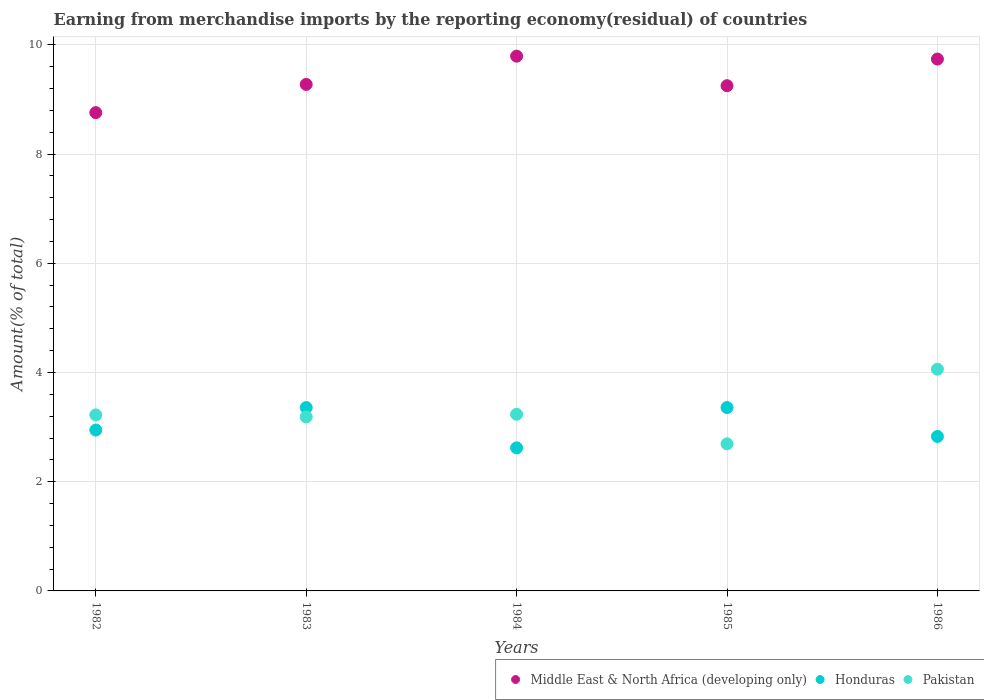How many different coloured dotlines are there?
Provide a succinct answer. 3. Is the number of dotlines equal to the number of legend labels?
Keep it short and to the point. Yes. What is the percentage of amount earned from merchandise imports in Middle East & North Africa (developing only) in 1984?
Provide a succinct answer. 9.79. Across all years, what is the maximum percentage of amount earned from merchandise imports in Honduras?
Ensure brevity in your answer.  3.36. Across all years, what is the minimum percentage of amount earned from merchandise imports in Honduras?
Offer a terse response. 2.62. What is the total percentage of amount earned from merchandise imports in Middle East & North Africa (developing only) in the graph?
Give a very brief answer. 46.82. What is the difference between the percentage of amount earned from merchandise imports in Pakistan in 1982 and that in 1983?
Your answer should be compact. 0.04. What is the difference between the percentage of amount earned from merchandise imports in Pakistan in 1983 and the percentage of amount earned from merchandise imports in Middle East & North Africa (developing only) in 1982?
Make the answer very short. -5.57. What is the average percentage of amount earned from merchandise imports in Honduras per year?
Keep it short and to the point. 3.02. In the year 1986, what is the difference between the percentage of amount earned from merchandise imports in Pakistan and percentage of amount earned from merchandise imports in Honduras?
Provide a succinct answer. 1.23. In how many years, is the percentage of amount earned from merchandise imports in Pakistan greater than 4 %?
Give a very brief answer. 1. What is the ratio of the percentage of amount earned from merchandise imports in Pakistan in 1983 to that in 1985?
Provide a short and direct response. 1.18. Is the percentage of amount earned from merchandise imports in Pakistan in 1982 less than that in 1984?
Give a very brief answer. Yes. What is the difference between the highest and the second highest percentage of amount earned from merchandise imports in Honduras?
Provide a short and direct response. 4.01576993880326e-9. What is the difference between the highest and the lowest percentage of amount earned from merchandise imports in Honduras?
Offer a terse response. 0.74. Is the sum of the percentage of amount earned from merchandise imports in Honduras in 1983 and 1986 greater than the maximum percentage of amount earned from merchandise imports in Middle East & North Africa (developing only) across all years?
Make the answer very short. No. Does the percentage of amount earned from merchandise imports in Honduras monotonically increase over the years?
Give a very brief answer. No. Is the percentage of amount earned from merchandise imports in Pakistan strictly greater than the percentage of amount earned from merchandise imports in Middle East & North Africa (developing only) over the years?
Offer a very short reply. No. How many dotlines are there?
Keep it short and to the point. 3. How many years are there in the graph?
Your answer should be very brief. 5. Are the values on the major ticks of Y-axis written in scientific E-notation?
Your answer should be compact. No. Does the graph contain any zero values?
Offer a very short reply. No. Does the graph contain grids?
Your answer should be compact. Yes. Where does the legend appear in the graph?
Make the answer very short. Bottom right. What is the title of the graph?
Your answer should be compact. Earning from merchandise imports by the reporting economy(residual) of countries. Does "Finland" appear as one of the legend labels in the graph?
Your response must be concise. No. What is the label or title of the Y-axis?
Keep it short and to the point. Amount(% of total). What is the Amount(% of total) in Middle East & North Africa (developing only) in 1982?
Your response must be concise. 8.76. What is the Amount(% of total) of Honduras in 1982?
Your answer should be compact. 2.95. What is the Amount(% of total) of Pakistan in 1982?
Ensure brevity in your answer.  3.22. What is the Amount(% of total) of Middle East & North Africa (developing only) in 1983?
Provide a short and direct response. 9.28. What is the Amount(% of total) of Honduras in 1983?
Make the answer very short. 3.36. What is the Amount(% of total) of Pakistan in 1983?
Offer a terse response. 3.19. What is the Amount(% of total) of Middle East & North Africa (developing only) in 1984?
Offer a very short reply. 9.79. What is the Amount(% of total) in Honduras in 1984?
Provide a short and direct response. 2.62. What is the Amount(% of total) of Pakistan in 1984?
Give a very brief answer. 3.23. What is the Amount(% of total) in Middle East & North Africa (developing only) in 1985?
Make the answer very short. 9.25. What is the Amount(% of total) of Honduras in 1985?
Keep it short and to the point. 3.36. What is the Amount(% of total) in Pakistan in 1985?
Your answer should be very brief. 2.69. What is the Amount(% of total) of Middle East & North Africa (developing only) in 1986?
Give a very brief answer. 9.74. What is the Amount(% of total) in Honduras in 1986?
Ensure brevity in your answer.  2.83. What is the Amount(% of total) of Pakistan in 1986?
Offer a very short reply. 4.06. Across all years, what is the maximum Amount(% of total) in Middle East & North Africa (developing only)?
Offer a terse response. 9.79. Across all years, what is the maximum Amount(% of total) of Honduras?
Your response must be concise. 3.36. Across all years, what is the maximum Amount(% of total) of Pakistan?
Your answer should be compact. 4.06. Across all years, what is the minimum Amount(% of total) in Middle East & North Africa (developing only)?
Provide a succinct answer. 8.76. Across all years, what is the minimum Amount(% of total) in Honduras?
Give a very brief answer. 2.62. Across all years, what is the minimum Amount(% of total) of Pakistan?
Keep it short and to the point. 2.69. What is the total Amount(% of total) of Middle East & North Africa (developing only) in the graph?
Your response must be concise. 46.82. What is the total Amount(% of total) in Honduras in the graph?
Offer a very short reply. 15.11. What is the total Amount(% of total) in Pakistan in the graph?
Provide a succinct answer. 16.4. What is the difference between the Amount(% of total) of Middle East & North Africa (developing only) in 1982 and that in 1983?
Offer a very short reply. -0.52. What is the difference between the Amount(% of total) in Honduras in 1982 and that in 1983?
Your answer should be very brief. -0.41. What is the difference between the Amount(% of total) in Pakistan in 1982 and that in 1983?
Offer a terse response. 0.04. What is the difference between the Amount(% of total) of Middle East & North Africa (developing only) in 1982 and that in 1984?
Provide a succinct answer. -1.03. What is the difference between the Amount(% of total) in Honduras in 1982 and that in 1984?
Offer a terse response. 0.33. What is the difference between the Amount(% of total) in Pakistan in 1982 and that in 1984?
Your answer should be compact. -0.01. What is the difference between the Amount(% of total) in Middle East & North Africa (developing only) in 1982 and that in 1985?
Give a very brief answer. -0.49. What is the difference between the Amount(% of total) of Honduras in 1982 and that in 1985?
Provide a short and direct response. -0.41. What is the difference between the Amount(% of total) of Pakistan in 1982 and that in 1985?
Offer a terse response. 0.53. What is the difference between the Amount(% of total) of Middle East & North Africa (developing only) in 1982 and that in 1986?
Offer a terse response. -0.98. What is the difference between the Amount(% of total) in Honduras in 1982 and that in 1986?
Provide a succinct answer. 0.12. What is the difference between the Amount(% of total) of Pakistan in 1982 and that in 1986?
Offer a very short reply. -0.84. What is the difference between the Amount(% of total) of Middle East & North Africa (developing only) in 1983 and that in 1984?
Provide a short and direct response. -0.52. What is the difference between the Amount(% of total) of Honduras in 1983 and that in 1984?
Your answer should be compact. 0.74. What is the difference between the Amount(% of total) of Pakistan in 1983 and that in 1984?
Offer a terse response. -0.05. What is the difference between the Amount(% of total) in Middle East & North Africa (developing only) in 1983 and that in 1985?
Provide a succinct answer. 0.02. What is the difference between the Amount(% of total) in Pakistan in 1983 and that in 1985?
Offer a terse response. 0.49. What is the difference between the Amount(% of total) in Middle East & North Africa (developing only) in 1983 and that in 1986?
Offer a terse response. -0.46. What is the difference between the Amount(% of total) of Honduras in 1983 and that in 1986?
Provide a short and direct response. 0.53. What is the difference between the Amount(% of total) in Pakistan in 1983 and that in 1986?
Your answer should be very brief. -0.87. What is the difference between the Amount(% of total) of Middle East & North Africa (developing only) in 1984 and that in 1985?
Offer a terse response. 0.54. What is the difference between the Amount(% of total) in Honduras in 1984 and that in 1985?
Provide a succinct answer. -0.74. What is the difference between the Amount(% of total) of Pakistan in 1984 and that in 1985?
Provide a short and direct response. 0.54. What is the difference between the Amount(% of total) of Middle East & North Africa (developing only) in 1984 and that in 1986?
Your response must be concise. 0.05. What is the difference between the Amount(% of total) in Honduras in 1984 and that in 1986?
Keep it short and to the point. -0.21. What is the difference between the Amount(% of total) of Pakistan in 1984 and that in 1986?
Provide a succinct answer. -0.83. What is the difference between the Amount(% of total) of Middle East & North Africa (developing only) in 1985 and that in 1986?
Keep it short and to the point. -0.49. What is the difference between the Amount(% of total) of Honduras in 1985 and that in 1986?
Your answer should be compact. 0.53. What is the difference between the Amount(% of total) in Pakistan in 1985 and that in 1986?
Your response must be concise. -1.37. What is the difference between the Amount(% of total) in Middle East & North Africa (developing only) in 1982 and the Amount(% of total) in Honduras in 1983?
Your response must be concise. 5.4. What is the difference between the Amount(% of total) in Middle East & North Africa (developing only) in 1982 and the Amount(% of total) in Pakistan in 1983?
Your answer should be very brief. 5.57. What is the difference between the Amount(% of total) in Honduras in 1982 and the Amount(% of total) in Pakistan in 1983?
Your answer should be very brief. -0.24. What is the difference between the Amount(% of total) of Middle East & North Africa (developing only) in 1982 and the Amount(% of total) of Honduras in 1984?
Provide a succinct answer. 6.14. What is the difference between the Amount(% of total) in Middle East & North Africa (developing only) in 1982 and the Amount(% of total) in Pakistan in 1984?
Offer a very short reply. 5.52. What is the difference between the Amount(% of total) of Honduras in 1982 and the Amount(% of total) of Pakistan in 1984?
Keep it short and to the point. -0.29. What is the difference between the Amount(% of total) of Middle East & North Africa (developing only) in 1982 and the Amount(% of total) of Honduras in 1985?
Your answer should be compact. 5.4. What is the difference between the Amount(% of total) of Middle East & North Africa (developing only) in 1982 and the Amount(% of total) of Pakistan in 1985?
Your response must be concise. 6.07. What is the difference between the Amount(% of total) of Honduras in 1982 and the Amount(% of total) of Pakistan in 1985?
Ensure brevity in your answer.  0.25. What is the difference between the Amount(% of total) of Middle East & North Africa (developing only) in 1982 and the Amount(% of total) of Honduras in 1986?
Ensure brevity in your answer.  5.93. What is the difference between the Amount(% of total) in Middle East & North Africa (developing only) in 1982 and the Amount(% of total) in Pakistan in 1986?
Offer a very short reply. 4.7. What is the difference between the Amount(% of total) in Honduras in 1982 and the Amount(% of total) in Pakistan in 1986?
Provide a succinct answer. -1.11. What is the difference between the Amount(% of total) in Middle East & North Africa (developing only) in 1983 and the Amount(% of total) in Honduras in 1984?
Provide a short and direct response. 6.66. What is the difference between the Amount(% of total) of Middle East & North Africa (developing only) in 1983 and the Amount(% of total) of Pakistan in 1984?
Keep it short and to the point. 6.04. What is the difference between the Amount(% of total) in Honduras in 1983 and the Amount(% of total) in Pakistan in 1984?
Your answer should be compact. 0.12. What is the difference between the Amount(% of total) of Middle East & North Africa (developing only) in 1983 and the Amount(% of total) of Honduras in 1985?
Offer a very short reply. 5.92. What is the difference between the Amount(% of total) in Middle East & North Africa (developing only) in 1983 and the Amount(% of total) in Pakistan in 1985?
Offer a terse response. 6.58. What is the difference between the Amount(% of total) in Honduras in 1983 and the Amount(% of total) in Pakistan in 1985?
Keep it short and to the point. 0.66. What is the difference between the Amount(% of total) of Middle East & North Africa (developing only) in 1983 and the Amount(% of total) of Honduras in 1986?
Keep it short and to the point. 6.45. What is the difference between the Amount(% of total) of Middle East & North Africa (developing only) in 1983 and the Amount(% of total) of Pakistan in 1986?
Ensure brevity in your answer.  5.21. What is the difference between the Amount(% of total) of Honduras in 1983 and the Amount(% of total) of Pakistan in 1986?
Offer a terse response. -0.7. What is the difference between the Amount(% of total) in Middle East & North Africa (developing only) in 1984 and the Amount(% of total) in Honduras in 1985?
Give a very brief answer. 6.43. What is the difference between the Amount(% of total) in Middle East & North Africa (developing only) in 1984 and the Amount(% of total) in Pakistan in 1985?
Offer a very short reply. 7.1. What is the difference between the Amount(% of total) of Honduras in 1984 and the Amount(% of total) of Pakistan in 1985?
Offer a very short reply. -0.07. What is the difference between the Amount(% of total) of Middle East & North Africa (developing only) in 1984 and the Amount(% of total) of Honduras in 1986?
Keep it short and to the point. 6.96. What is the difference between the Amount(% of total) of Middle East & North Africa (developing only) in 1984 and the Amount(% of total) of Pakistan in 1986?
Keep it short and to the point. 5.73. What is the difference between the Amount(% of total) in Honduras in 1984 and the Amount(% of total) in Pakistan in 1986?
Give a very brief answer. -1.44. What is the difference between the Amount(% of total) in Middle East & North Africa (developing only) in 1985 and the Amount(% of total) in Honduras in 1986?
Offer a terse response. 6.42. What is the difference between the Amount(% of total) of Middle East & North Africa (developing only) in 1985 and the Amount(% of total) of Pakistan in 1986?
Offer a terse response. 5.19. What is the difference between the Amount(% of total) in Honduras in 1985 and the Amount(% of total) in Pakistan in 1986?
Provide a short and direct response. -0.7. What is the average Amount(% of total) of Middle East & North Africa (developing only) per year?
Keep it short and to the point. 9.36. What is the average Amount(% of total) in Honduras per year?
Your answer should be compact. 3.02. What is the average Amount(% of total) in Pakistan per year?
Provide a succinct answer. 3.28. In the year 1982, what is the difference between the Amount(% of total) of Middle East & North Africa (developing only) and Amount(% of total) of Honduras?
Provide a short and direct response. 5.81. In the year 1982, what is the difference between the Amount(% of total) in Middle East & North Africa (developing only) and Amount(% of total) in Pakistan?
Offer a very short reply. 5.54. In the year 1982, what is the difference between the Amount(% of total) in Honduras and Amount(% of total) in Pakistan?
Keep it short and to the point. -0.28. In the year 1983, what is the difference between the Amount(% of total) of Middle East & North Africa (developing only) and Amount(% of total) of Honduras?
Offer a very short reply. 5.92. In the year 1983, what is the difference between the Amount(% of total) of Middle East & North Africa (developing only) and Amount(% of total) of Pakistan?
Ensure brevity in your answer.  6.09. In the year 1983, what is the difference between the Amount(% of total) of Honduras and Amount(% of total) of Pakistan?
Offer a terse response. 0.17. In the year 1984, what is the difference between the Amount(% of total) in Middle East & North Africa (developing only) and Amount(% of total) in Honduras?
Ensure brevity in your answer.  7.17. In the year 1984, what is the difference between the Amount(% of total) in Middle East & North Africa (developing only) and Amount(% of total) in Pakistan?
Your answer should be compact. 6.56. In the year 1984, what is the difference between the Amount(% of total) of Honduras and Amount(% of total) of Pakistan?
Your answer should be compact. -0.61. In the year 1985, what is the difference between the Amount(% of total) in Middle East & North Africa (developing only) and Amount(% of total) in Honduras?
Provide a succinct answer. 5.89. In the year 1985, what is the difference between the Amount(% of total) of Middle East & North Africa (developing only) and Amount(% of total) of Pakistan?
Your answer should be very brief. 6.56. In the year 1985, what is the difference between the Amount(% of total) in Honduras and Amount(% of total) in Pakistan?
Keep it short and to the point. 0.66. In the year 1986, what is the difference between the Amount(% of total) of Middle East & North Africa (developing only) and Amount(% of total) of Honduras?
Offer a terse response. 6.91. In the year 1986, what is the difference between the Amount(% of total) of Middle East & North Africa (developing only) and Amount(% of total) of Pakistan?
Offer a terse response. 5.68. In the year 1986, what is the difference between the Amount(% of total) in Honduras and Amount(% of total) in Pakistan?
Keep it short and to the point. -1.23. What is the ratio of the Amount(% of total) in Middle East & North Africa (developing only) in 1982 to that in 1983?
Offer a very short reply. 0.94. What is the ratio of the Amount(% of total) of Honduras in 1982 to that in 1983?
Make the answer very short. 0.88. What is the ratio of the Amount(% of total) in Pakistan in 1982 to that in 1983?
Ensure brevity in your answer.  1.01. What is the ratio of the Amount(% of total) in Middle East & North Africa (developing only) in 1982 to that in 1984?
Give a very brief answer. 0.89. What is the ratio of the Amount(% of total) of Honduras in 1982 to that in 1984?
Keep it short and to the point. 1.12. What is the ratio of the Amount(% of total) of Pakistan in 1982 to that in 1984?
Keep it short and to the point. 1. What is the ratio of the Amount(% of total) of Middle East & North Africa (developing only) in 1982 to that in 1985?
Offer a terse response. 0.95. What is the ratio of the Amount(% of total) of Honduras in 1982 to that in 1985?
Your answer should be very brief. 0.88. What is the ratio of the Amount(% of total) of Pakistan in 1982 to that in 1985?
Give a very brief answer. 1.2. What is the ratio of the Amount(% of total) of Middle East & North Africa (developing only) in 1982 to that in 1986?
Provide a short and direct response. 0.9. What is the ratio of the Amount(% of total) of Honduras in 1982 to that in 1986?
Provide a short and direct response. 1.04. What is the ratio of the Amount(% of total) of Pakistan in 1982 to that in 1986?
Offer a terse response. 0.79. What is the ratio of the Amount(% of total) in Middle East & North Africa (developing only) in 1983 to that in 1984?
Make the answer very short. 0.95. What is the ratio of the Amount(% of total) in Honduras in 1983 to that in 1984?
Provide a short and direct response. 1.28. What is the ratio of the Amount(% of total) in Pakistan in 1983 to that in 1984?
Offer a very short reply. 0.99. What is the ratio of the Amount(% of total) in Middle East & North Africa (developing only) in 1983 to that in 1985?
Keep it short and to the point. 1. What is the ratio of the Amount(% of total) in Pakistan in 1983 to that in 1985?
Offer a very short reply. 1.18. What is the ratio of the Amount(% of total) of Middle East & North Africa (developing only) in 1983 to that in 1986?
Your answer should be very brief. 0.95. What is the ratio of the Amount(% of total) in Honduras in 1983 to that in 1986?
Provide a succinct answer. 1.19. What is the ratio of the Amount(% of total) of Pakistan in 1983 to that in 1986?
Your answer should be compact. 0.78. What is the ratio of the Amount(% of total) in Middle East & North Africa (developing only) in 1984 to that in 1985?
Your answer should be very brief. 1.06. What is the ratio of the Amount(% of total) in Honduras in 1984 to that in 1985?
Ensure brevity in your answer.  0.78. What is the ratio of the Amount(% of total) of Pakistan in 1984 to that in 1985?
Your response must be concise. 1.2. What is the ratio of the Amount(% of total) in Honduras in 1984 to that in 1986?
Provide a short and direct response. 0.93. What is the ratio of the Amount(% of total) of Pakistan in 1984 to that in 1986?
Offer a terse response. 0.8. What is the ratio of the Amount(% of total) in Middle East & North Africa (developing only) in 1985 to that in 1986?
Offer a terse response. 0.95. What is the ratio of the Amount(% of total) in Honduras in 1985 to that in 1986?
Provide a short and direct response. 1.19. What is the ratio of the Amount(% of total) in Pakistan in 1985 to that in 1986?
Provide a succinct answer. 0.66. What is the difference between the highest and the second highest Amount(% of total) of Middle East & North Africa (developing only)?
Make the answer very short. 0.05. What is the difference between the highest and the second highest Amount(% of total) in Honduras?
Your answer should be compact. 0. What is the difference between the highest and the second highest Amount(% of total) of Pakistan?
Offer a terse response. 0.83. What is the difference between the highest and the lowest Amount(% of total) of Middle East & North Africa (developing only)?
Your response must be concise. 1.03. What is the difference between the highest and the lowest Amount(% of total) in Honduras?
Your answer should be very brief. 0.74. What is the difference between the highest and the lowest Amount(% of total) of Pakistan?
Offer a very short reply. 1.37. 